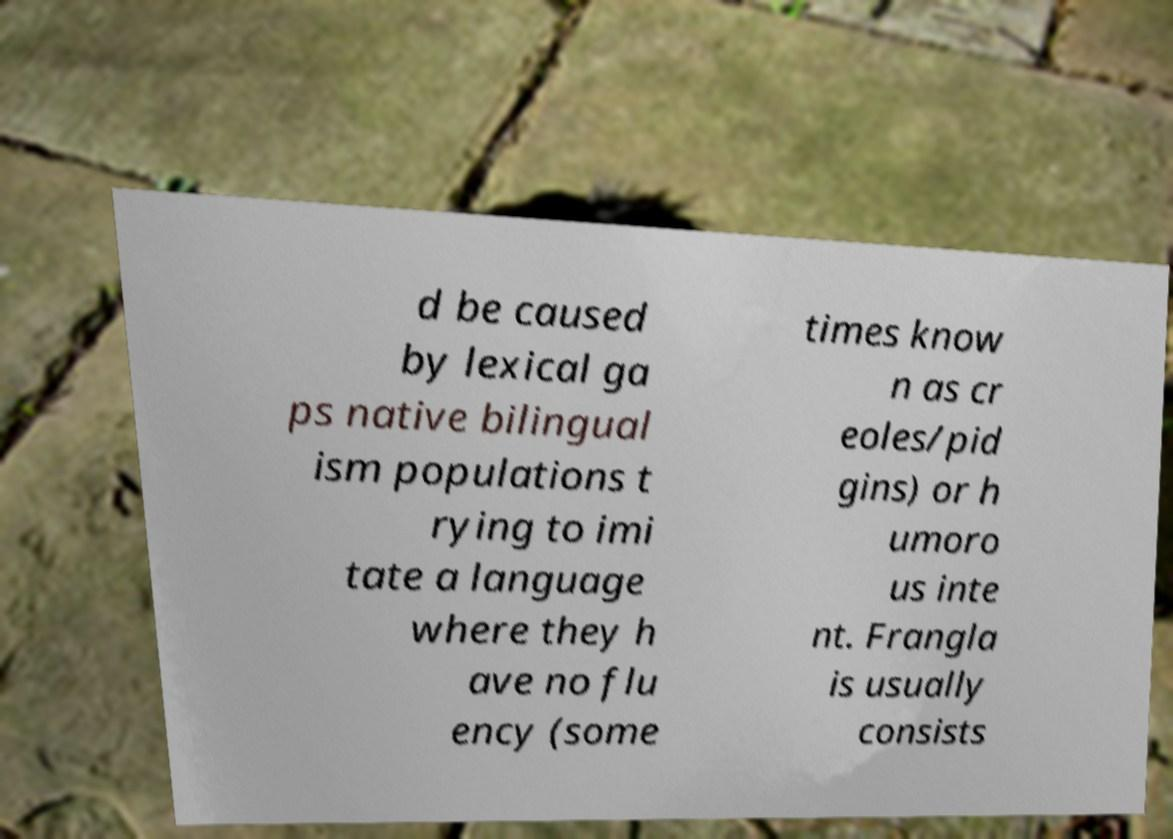What messages or text are displayed in this image? I need them in a readable, typed format. d be caused by lexical ga ps native bilingual ism populations t rying to imi tate a language where they h ave no flu ency (some times know n as cr eoles/pid gins) or h umoro us inte nt. Frangla is usually consists 